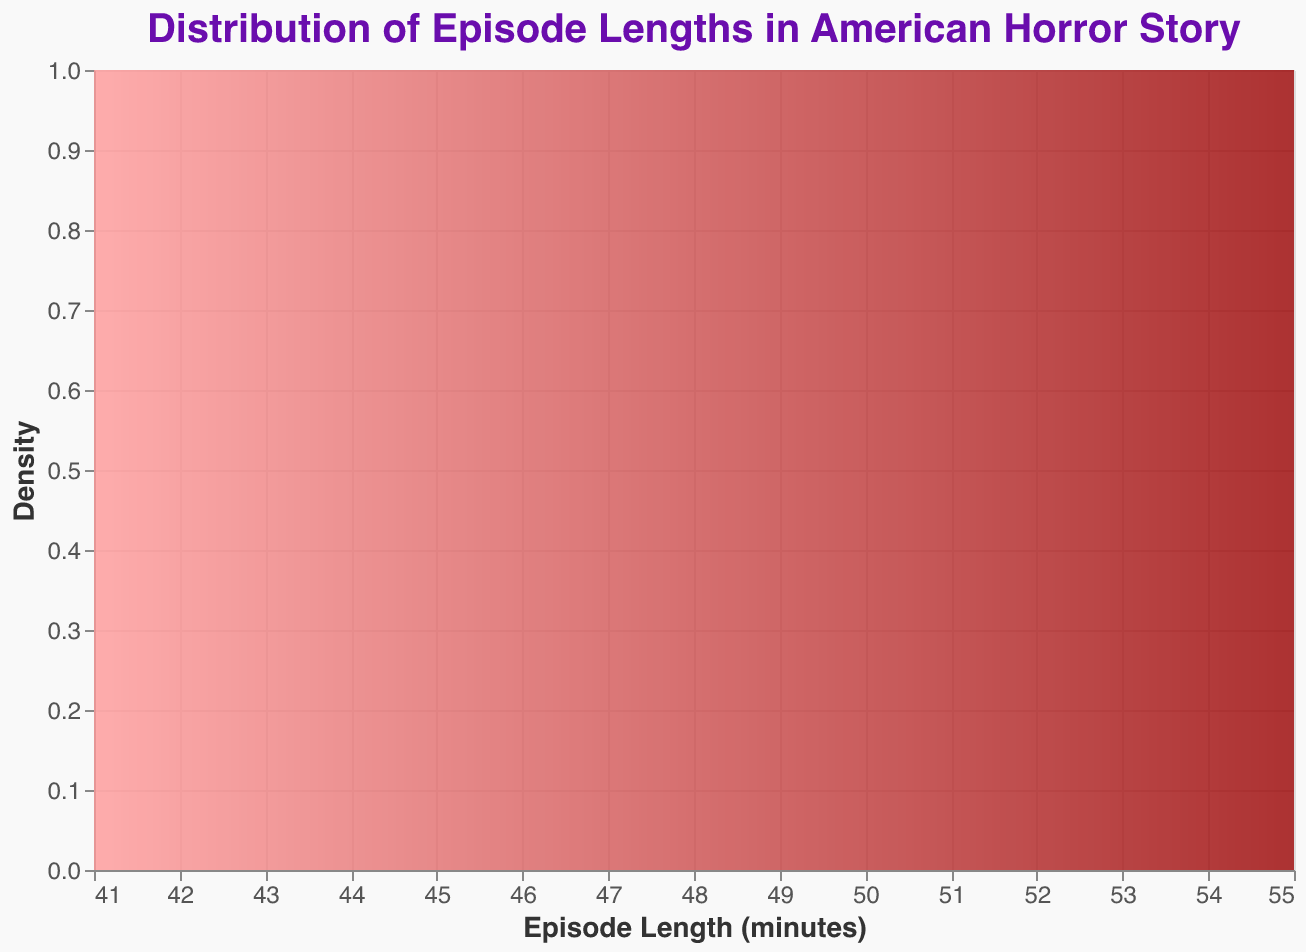What is the title of the plot? The title of the plot is prominently displayed at the top of the figure. It reads "Distribution of Episode Lengths in American Horror Story."
Answer: Distribution of Episode Lengths in American Horror Story What is the range of episode lengths displayed on the x-axis? The x-axis represents the episode lengths in minutes. By observing the axis, we can see that it ranges from 40 to 60 minutes.
Answer: 40 to 60 minutes Which season has episodes with the longest lengths? By inspecting the tooltip with the highest episode lengths in the density plot, we observe that "Double Feature" has the highest episode lengths of up to 55 minutes.
Answer: Double Feature Which season has the shortest episode length, and what is that length? By examining the density plot and checking the tooltip at the lowest length, we see that "Roanoke" has the shortest episode length of 41 minutes.
Answer: Roanoke, 41 minutes What is the episode length with the highest density? The density plot's peak represents the episode length where the density is highest. By looking at the highest point on the curve, we determine that it's around 45 to 48 minutes.
Answer: 45 to 48 minutes How many seasons have episodes that are exactly 45 minutes long? Observing the density plot tooltips for when the cursor is placed at 45 minutes, we see that "Murder House," "Roanoke," "Cult," and "1984" all appear, indicating 4 seasons.
Answer: 4 seasons Which season's episode lengths show the most significant variance? To determine this, we observe how spread out the densities are for the different seasons. "Double Feature," which ranges from 52 to 55 minutes, shows a noticeable spread, indicating significant variance.
Answer: Double Feature What is the average episode length for the season "Hotel"? By summing the episode lengths for "Hotel" (48, 51, 47) and dividing by the number of episodes (3), we calculate (48 + 51 + 47)/3 = 146/3 ≈48.67 minutes.
Answer: ≈48.67 minutes How many seasons have at least one episode longer than 50 minutes? By examining which seasons have a density in the plot beyond the 50-minute mark, we see that "Asylum," "Freak Show," "Hotel," "Apocalypse," and "Double Feature" meet this criterion, totaling 5 seasons.
Answer: 5 seasons 